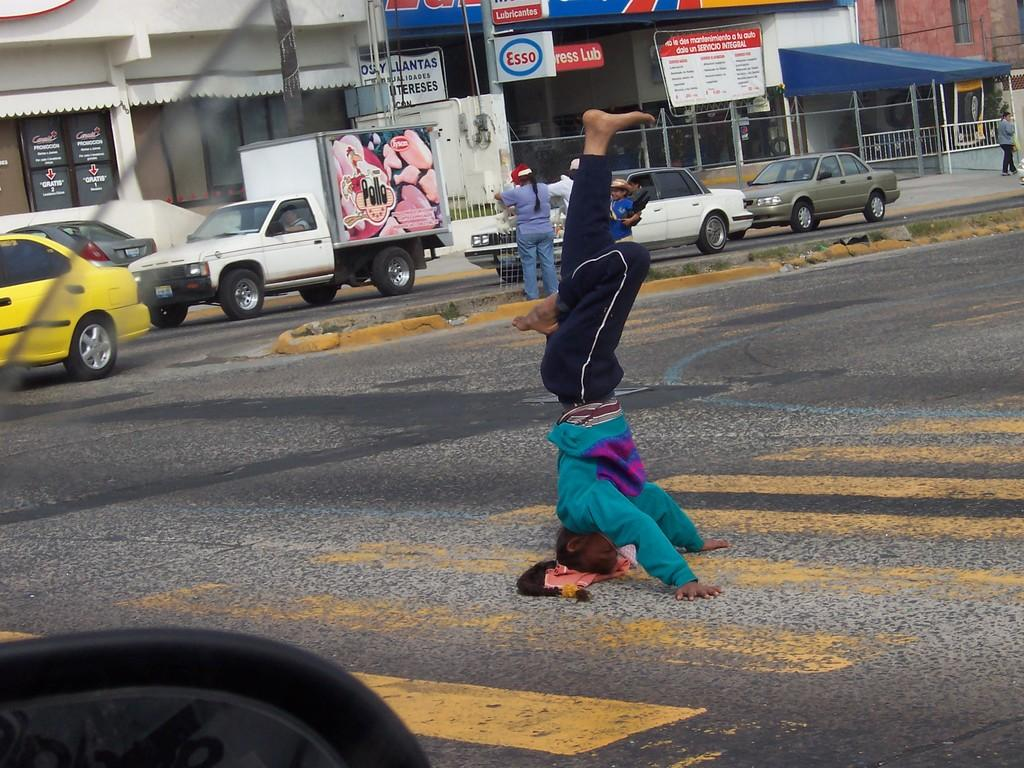<image>
Present a compact description of the photo's key features. A man stands on his head in the middle of a crosswalk with a Pollo truck in the background. 